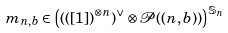Convert formula to latex. <formula><loc_0><loc_0><loc_500><loc_500>m _ { n , b } \in \left ( \left ( ( [ 1 ] \right ) ^ { \otimes n } ) ^ { \vee } \otimes \mathcal { P } ( ( n , b ) ) \right ) ^ { \mathbb { S } _ { n } }</formula> 